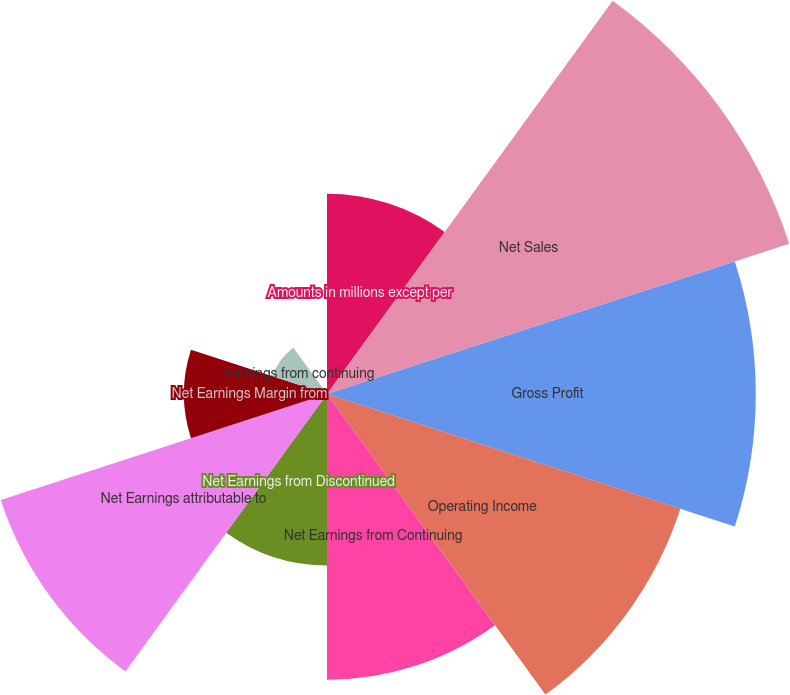Convert chart. <chart><loc_0><loc_0><loc_500><loc_500><pie_chart><fcel>Amounts in millions except per<fcel>Net Sales<fcel>Gross Profit<fcel>Operating Income<fcel>Net Earnings from Continuing<fcel>Net Earnings from Discontinued<fcel>Net Earnings attributable to<fcel>Net Earnings Margin from<fcel>Earnings from continuing<fcel>Earnings from discontinued<nl><fcel>8.05%<fcel>19.54%<fcel>17.24%<fcel>14.94%<fcel>11.49%<fcel>6.9%<fcel>13.79%<fcel>5.75%<fcel>2.3%<fcel>0.0%<nl></chart> 